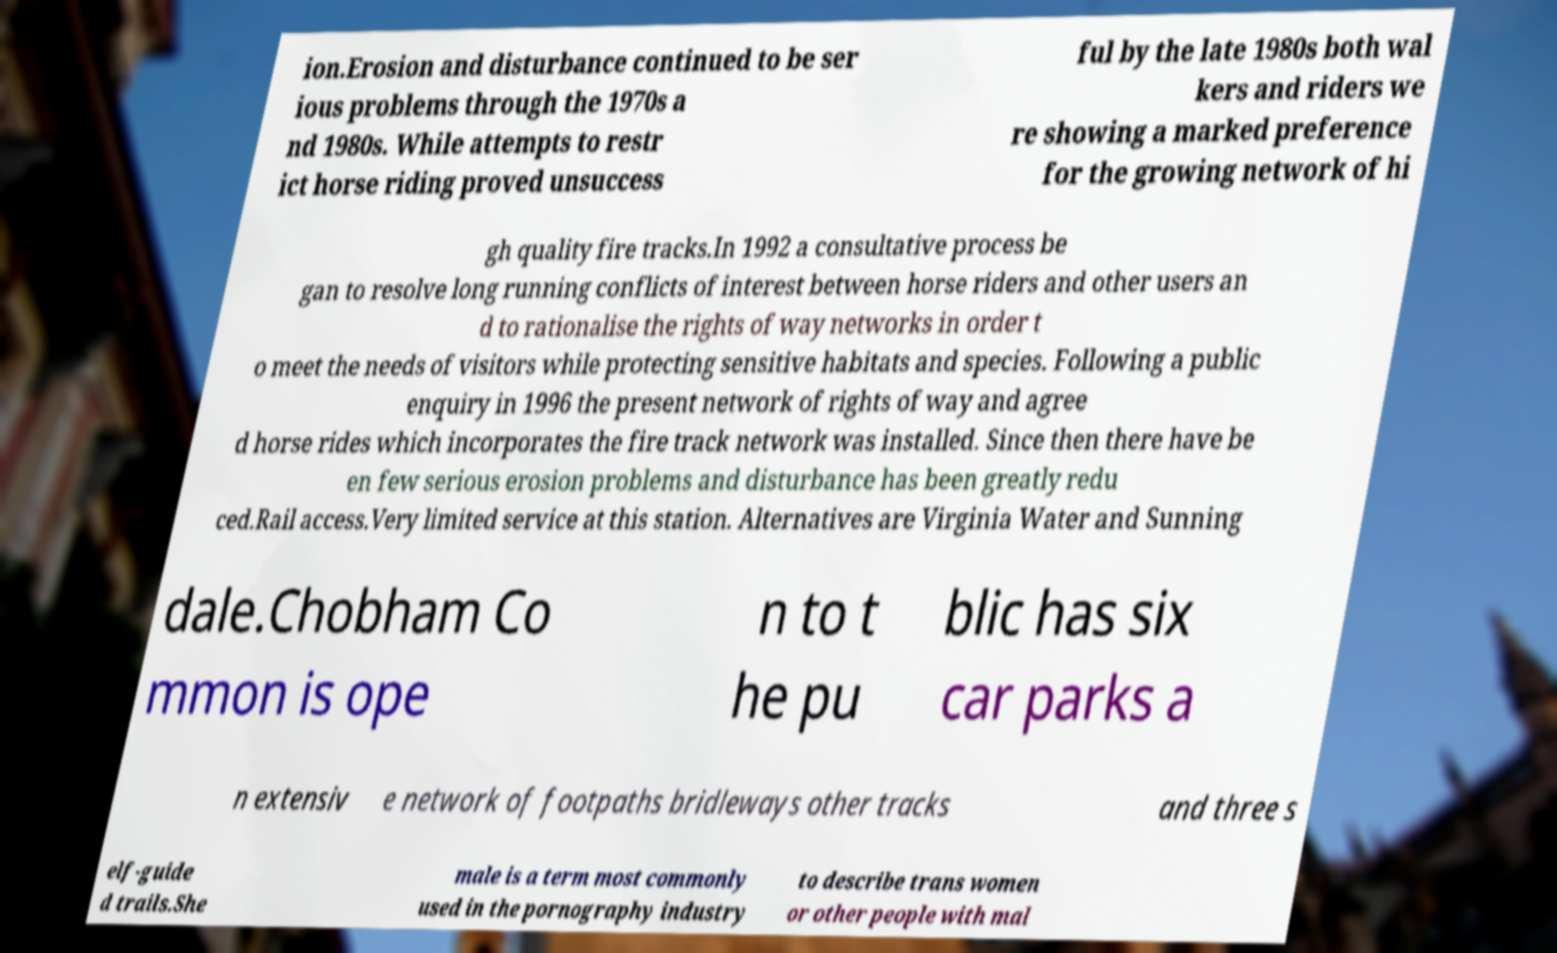Can you accurately transcribe the text from the provided image for me? ion.Erosion and disturbance continued to be ser ious problems through the 1970s a nd 1980s. While attempts to restr ict horse riding proved unsuccess ful by the late 1980s both wal kers and riders we re showing a marked preference for the growing network of hi gh quality fire tracks.In 1992 a consultative process be gan to resolve long running conflicts of interest between horse riders and other users an d to rationalise the rights of way networks in order t o meet the needs of visitors while protecting sensitive habitats and species. Following a public enquiry in 1996 the present network of rights of way and agree d horse rides which incorporates the fire track network was installed. Since then there have be en few serious erosion problems and disturbance has been greatly redu ced.Rail access.Very limited service at this station. Alternatives are Virginia Water and Sunning dale.Chobham Co mmon is ope n to t he pu blic has six car parks a n extensiv e network of footpaths bridleways other tracks and three s elf-guide d trails.She male is a term most commonly used in the pornography industry to describe trans women or other people with mal 